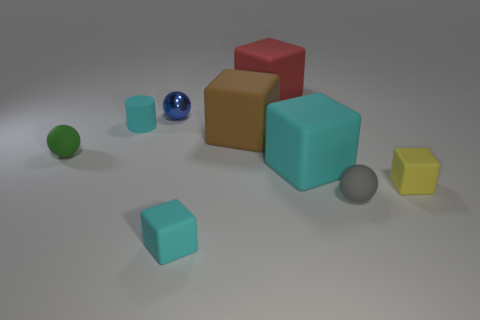Subtract all small cubes. How many cubes are left? 3 Subtract all blue balls. How many balls are left? 2 Subtract 2 balls. How many balls are left? 1 Subtract all cyan cubes. How many blue spheres are left? 1 Subtract all cylinders. How many objects are left? 8 Subtract all yellow spheres. Subtract all green blocks. How many spheres are left? 3 Add 2 tiny rubber cubes. How many tiny rubber cubes exist? 4 Subtract 2 cyan cubes. How many objects are left? 7 Subtract all small green metal balls. Subtract all small yellow rubber things. How many objects are left? 8 Add 9 large brown matte things. How many large brown matte things are left? 10 